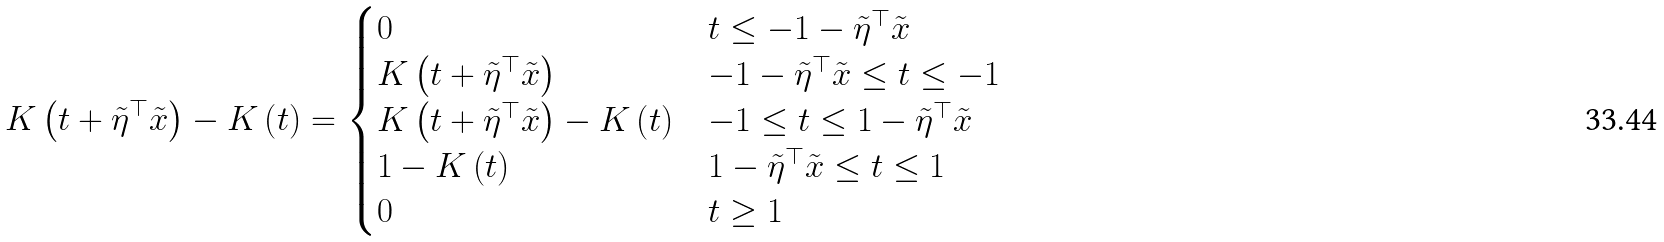<formula> <loc_0><loc_0><loc_500><loc_500>K \left ( t + \tilde { \eta } ^ { \top } \tilde { x } \right ) - K \left ( t \right ) = \begin{cases} 0 & \text {$t \leq -1-\tilde{\eta}^{\top}\tilde{x}$} \\ K \left ( t + \tilde { \eta } ^ { \top } \tilde { x } \right ) & \text {$-1-\tilde{\eta}^{\top}\tilde{x} \leq t \leq -1$} \\ K \left ( t + \tilde { \eta } ^ { \top } \tilde { x } \right ) - K \left ( t \right ) & \text {$-1 \leq t \leq 1-\tilde{\eta}^{\top}\tilde{x}$} \\ 1 - K \left ( t \right ) & \text {$1-\tilde{\eta}^{\top}\tilde{x} \leq t \leq 1$} \\ 0 & \text {$t \geq 1$} \end{cases}</formula> 